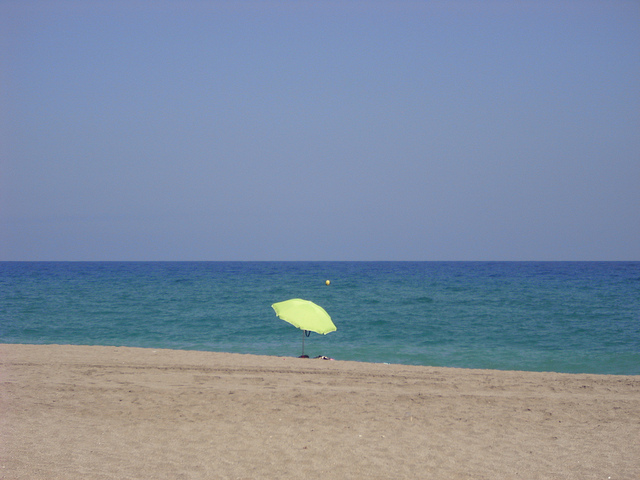What kind of location is depicted in the image? The image depicts a serene beach scene, likely on a calm day due to the smoothness of the sea and clear skies. The lack of people and minimalistic scene suggest a tranquil, possibly secluded beachfront. Are there any activities visible in the image or that might be suitable here? No specific activities are visible in the image, barring the presence of a solitary umbrella perhaps indicating someone sunbathing or enjoying the view. The setting would be ideal for beach walks, sunbathing, or swimming in the inviting blue waters. 